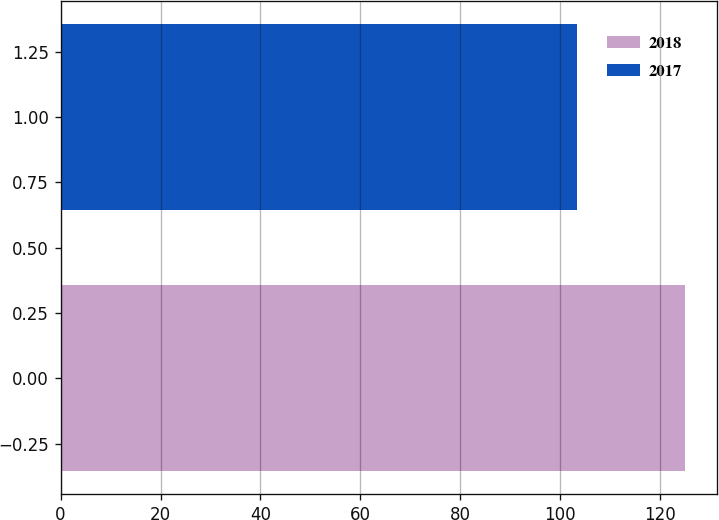Convert chart. <chart><loc_0><loc_0><loc_500><loc_500><bar_chart><fcel>2018<fcel>2017<nl><fcel>125.09<fcel>103.36<nl></chart> 